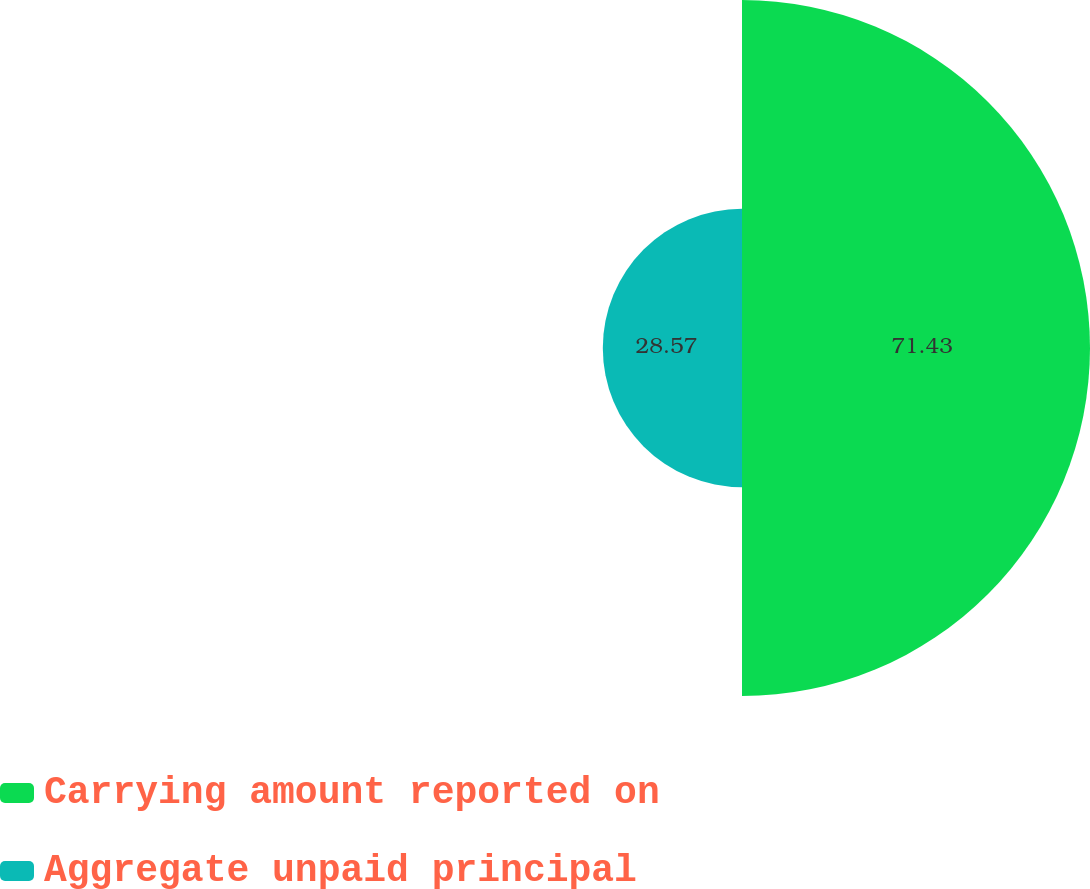Convert chart. <chart><loc_0><loc_0><loc_500><loc_500><pie_chart><fcel>Carrying amount reported on<fcel>Aggregate unpaid principal<nl><fcel>71.43%<fcel>28.57%<nl></chart> 